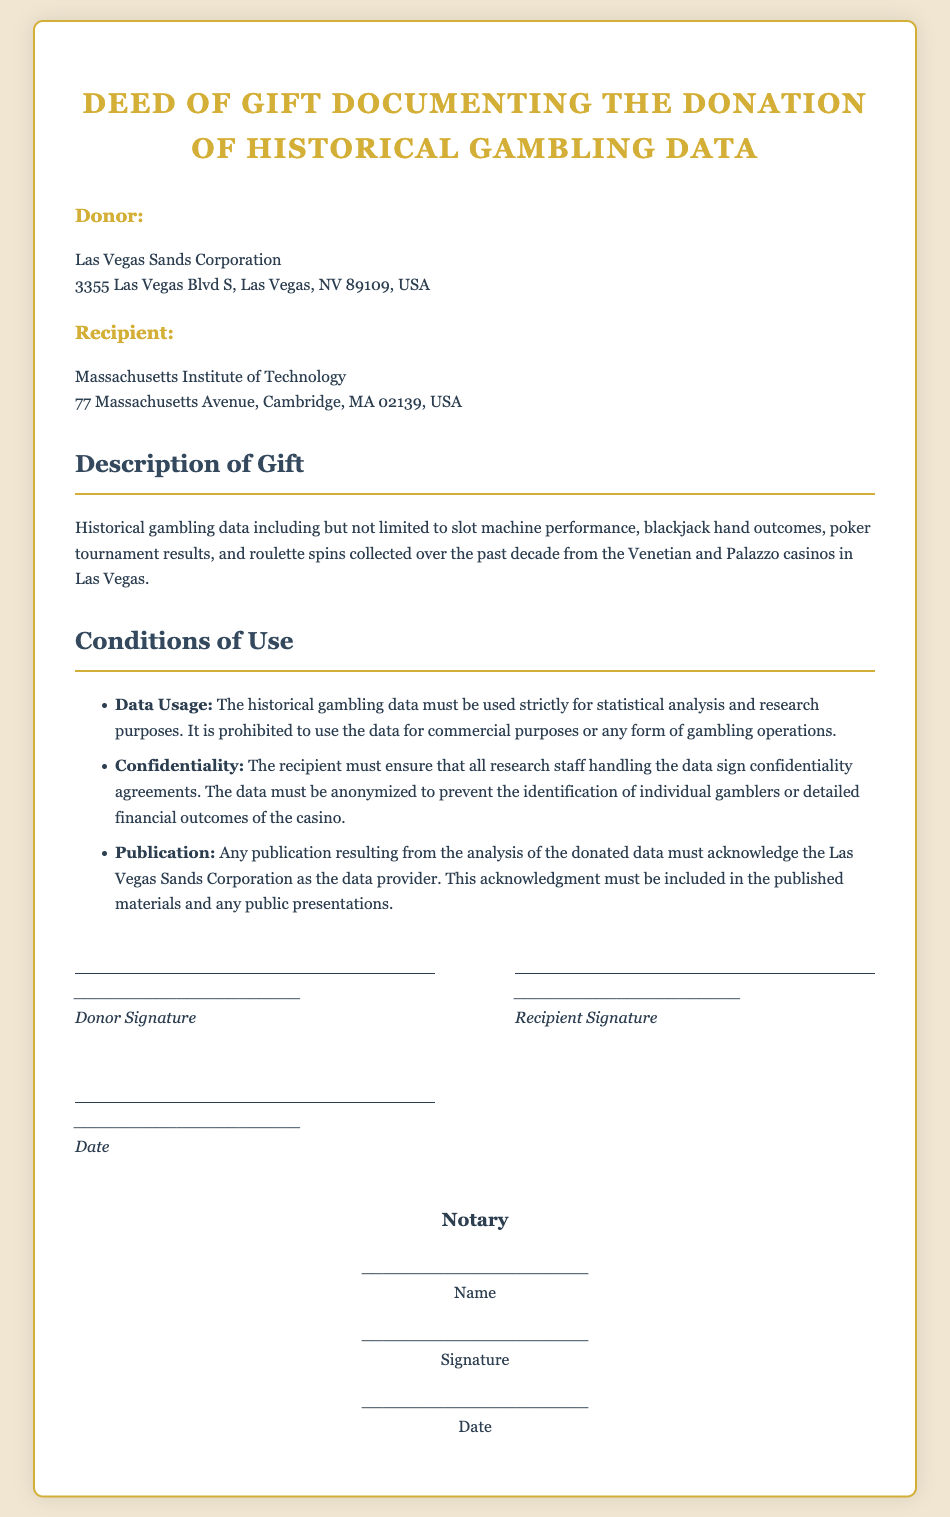What is the name of the donor? The document specifies the donor as "Las Vegas Sands Corporation".
Answer: Las Vegas Sands Corporation What is the address of the recipient? The recipient's address provided in the document is "77 Massachusetts Avenue, Cambridge, MA 02139, USA".
Answer: 77 Massachusetts Avenue, Cambridge, MA 02139, USA What type of data is being donated? The document mentions "historical gambling data including but not limited to slot machine performance, blackjack hand outcomes, poker tournament results, and roulette spins."
Answer: Historical gambling data What are the conditions of use related to data publication? The document states, "Any publication resulting from the analysis of the donated data must acknowledge the Las Vegas Sands Corporation as the data provider."
Answer: Acknowledge Las Vegas Sands Corporation How long was the historical gambling data collected? The document indicates that the data was collected "over the past decade."
Answer: Over the past decade What must the research staff sign to ensure confidentiality? It is specified that "the recipient must ensure that all research staff handling the data sign confidentiality agreements."
Answer: Confidentiality agreements What is prohibited regarding the use of the data? The document clearly states that "it is prohibited to use the data for commercial purposes or any form of gambling operations."
Answer: Commercial purposes or any form of gambling operations What is required to be included in publications? The document requires that "this acknowledgment must be included in the published materials and any public presentations."
Answer: Acknowledgment in published materials 